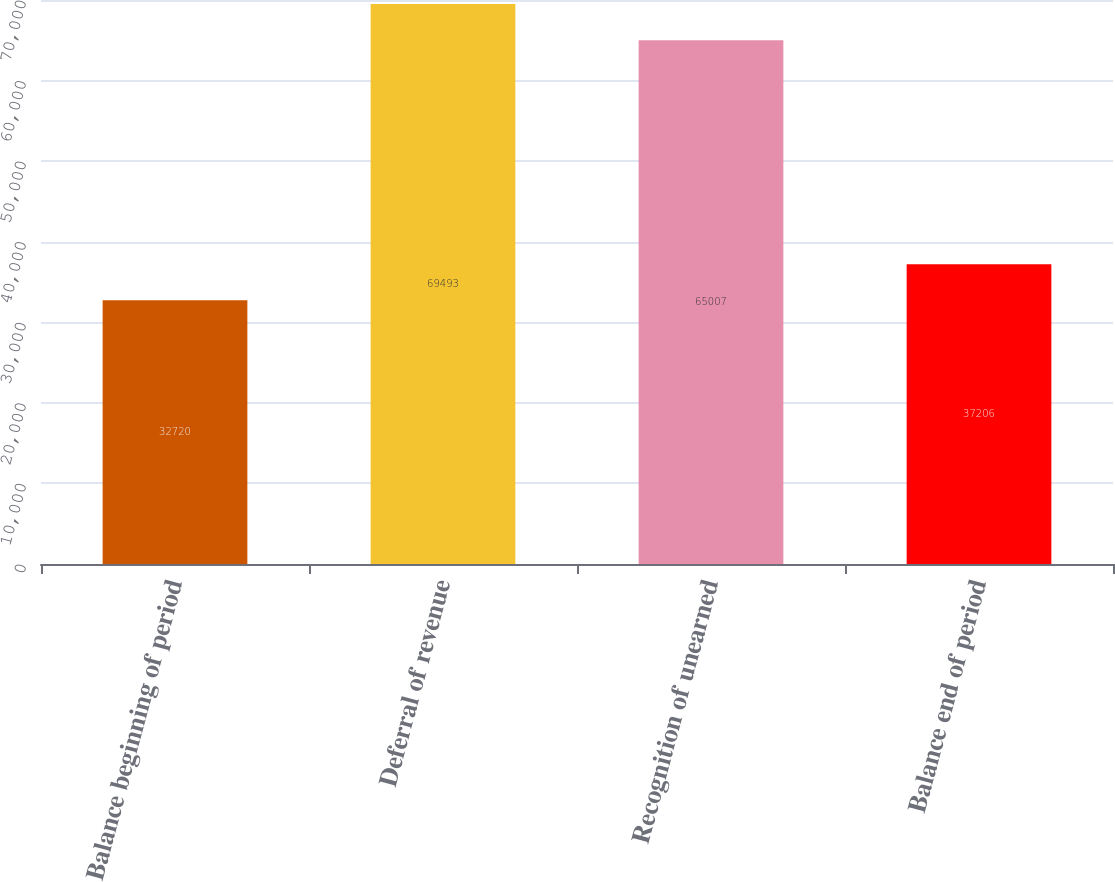Convert chart. <chart><loc_0><loc_0><loc_500><loc_500><bar_chart><fcel>Balance beginning of period<fcel>Deferral of revenue<fcel>Recognition of unearned<fcel>Balance end of period<nl><fcel>32720<fcel>69493<fcel>65007<fcel>37206<nl></chart> 